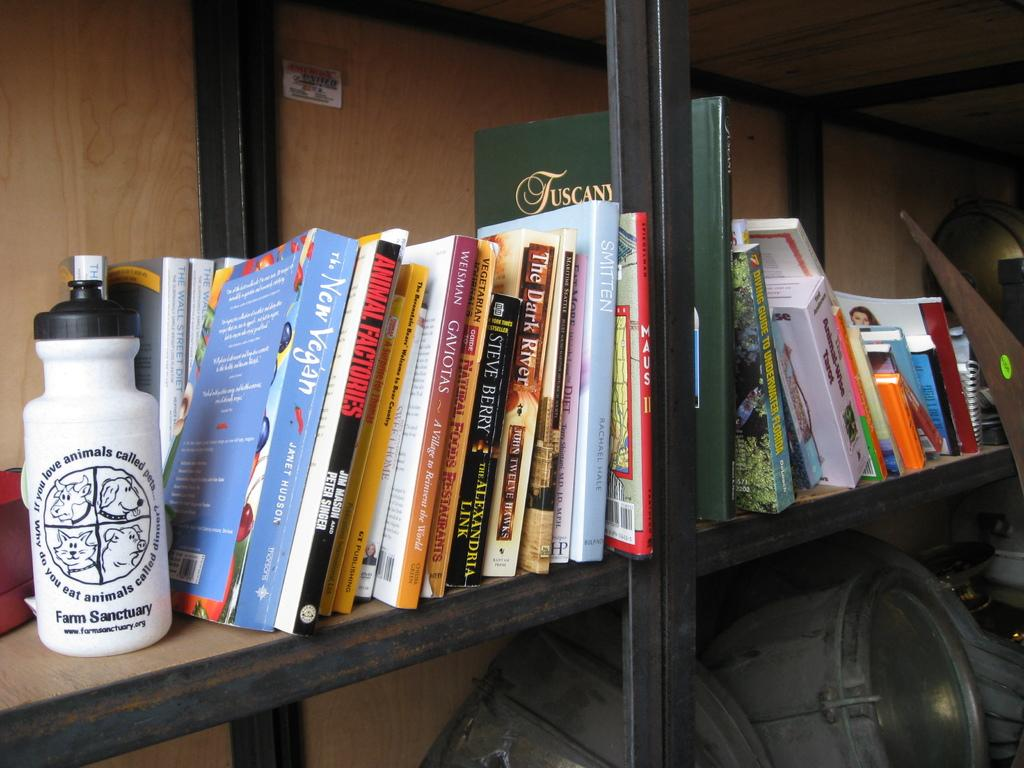<image>
Relay a brief, clear account of the picture shown. A water bottle from farm sanctuary is on the shelf next to different books. 